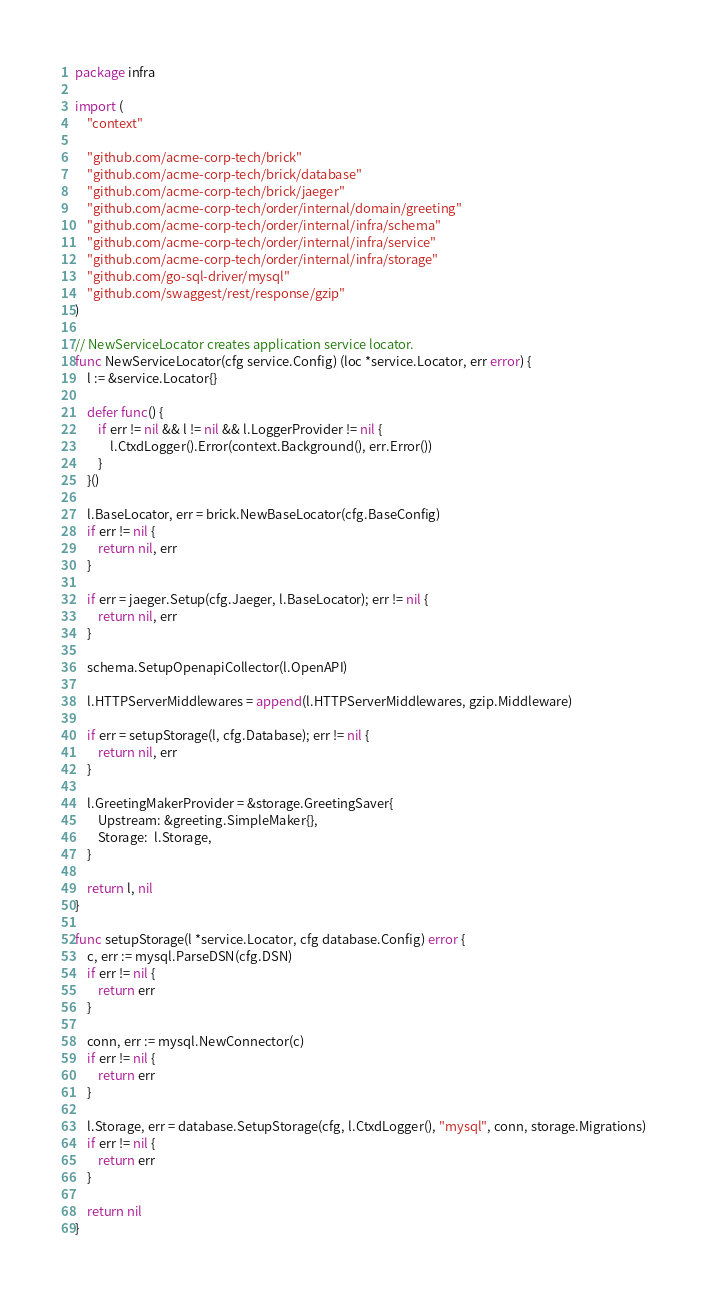Convert code to text. <code><loc_0><loc_0><loc_500><loc_500><_Go_>package infra

import (
	"context"

	"github.com/acme-corp-tech/brick"
	"github.com/acme-corp-tech/brick/database"
	"github.com/acme-corp-tech/brick/jaeger"
	"github.com/acme-corp-tech/order/internal/domain/greeting"
	"github.com/acme-corp-tech/order/internal/infra/schema"
	"github.com/acme-corp-tech/order/internal/infra/service"
	"github.com/acme-corp-tech/order/internal/infra/storage"
	"github.com/go-sql-driver/mysql"
	"github.com/swaggest/rest/response/gzip"
)

// NewServiceLocator creates application service locator.
func NewServiceLocator(cfg service.Config) (loc *service.Locator, err error) {
	l := &service.Locator{}

	defer func() {
		if err != nil && l != nil && l.LoggerProvider != nil {
			l.CtxdLogger().Error(context.Background(), err.Error())
		}
	}()

	l.BaseLocator, err = brick.NewBaseLocator(cfg.BaseConfig)
	if err != nil {
		return nil, err
	}

	if err = jaeger.Setup(cfg.Jaeger, l.BaseLocator); err != nil {
		return nil, err
	}

	schema.SetupOpenapiCollector(l.OpenAPI)

	l.HTTPServerMiddlewares = append(l.HTTPServerMiddlewares, gzip.Middleware)

	if err = setupStorage(l, cfg.Database); err != nil {
		return nil, err
	}

	l.GreetingMakerProvider = &storage.GreetingSaver{
		Upstream: &greeting.SimpleMaker{},
		Storage:  l.Storage,
	}

	return l, nil
}

func setupStorage(l *service.Locator, cfg database.Config) error {
	c, err := mysql.ParseDSN(cfg.DSN)
	if err != nil {
		return err
	}

	conn, err := mysql.NewConnector(c)
	if err != nil {
		return err
	}

	l.Storage, err = database.SetupStorage(cfg, l.CtxdLogger(), "mysql", conn, storage.Migrations)
	if err != nil {
		return err
	}

	return nil
}
</code> 